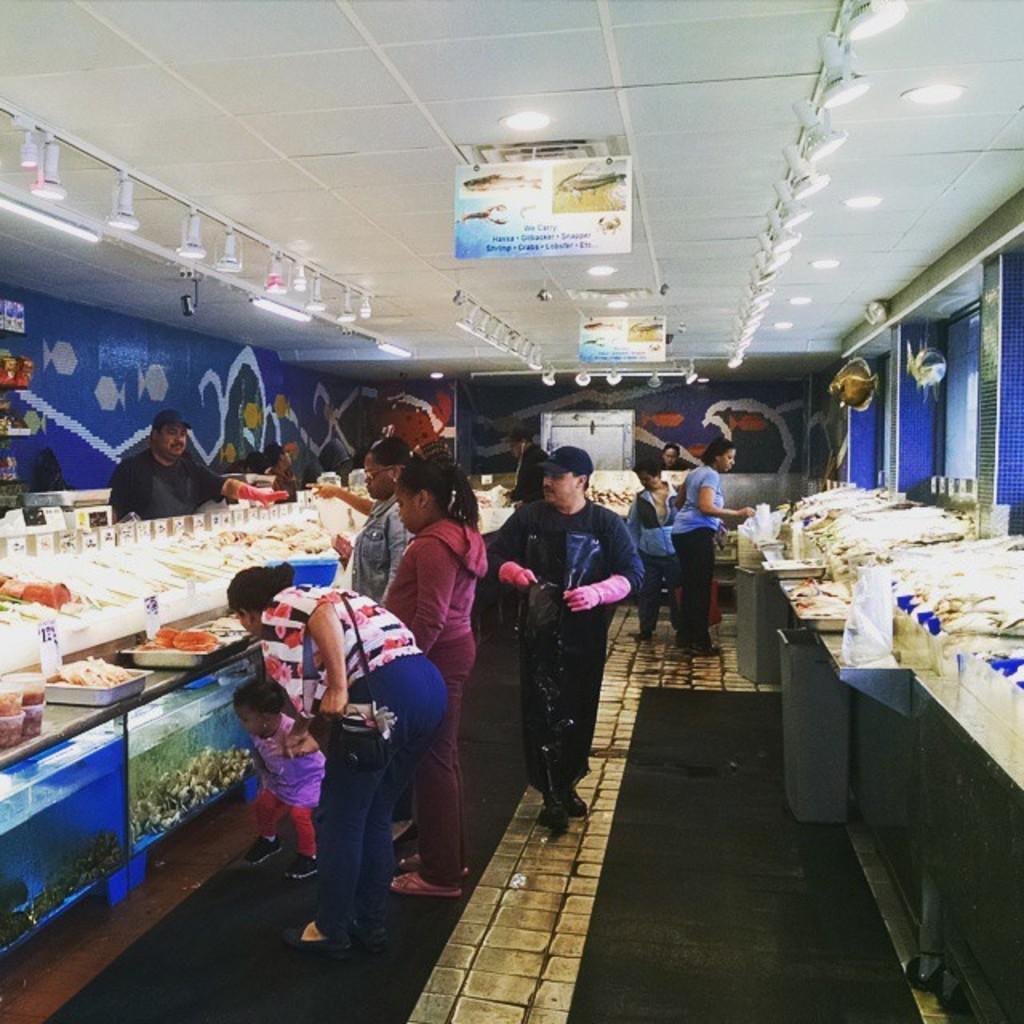Could you give a brief overview of what you see in this image? In this picture there are group of people standing and there are vegetables and objects on the table. At the bottom left there are aquariums. At the top there are boards and lights and there is text on the boards. At the bottom there is a floor. At the back there is painting on the wall. 